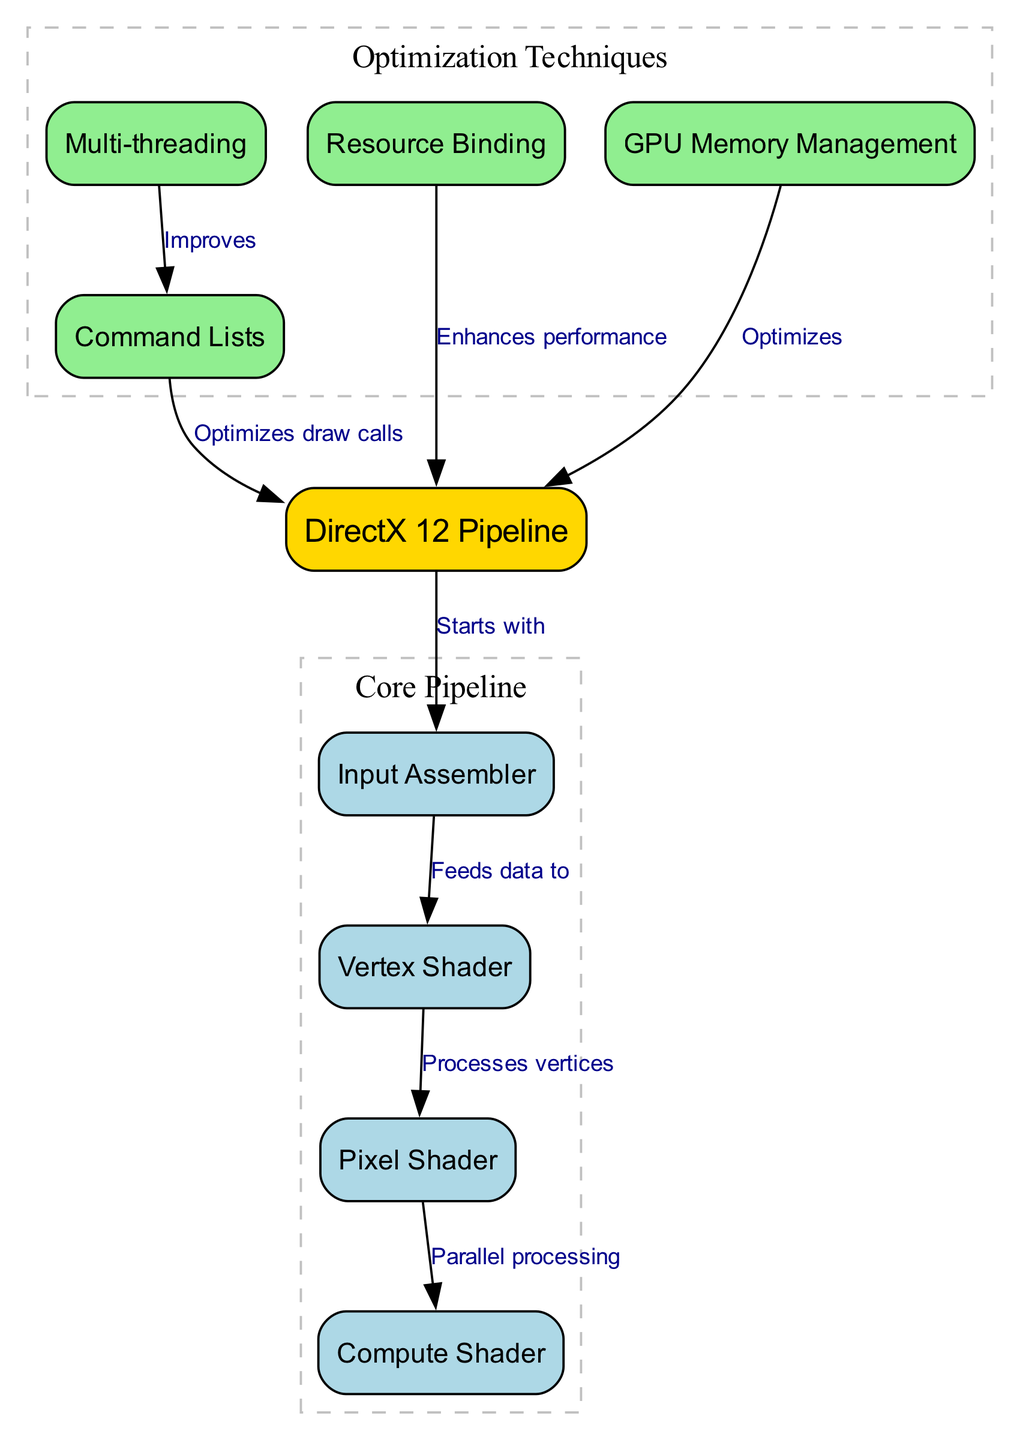What is the starting component of the DirectX 12 pipeline? The diagram indicates that the DirectX 12 Pipeline begins with the Input Assembler node, as it has an edge labeled "Starts with" leading from the DirectX 12 Pipeline to the Input Assembler.
Answer: Input Assembler How many components are in the core pipeline? The core pipeline comprises four key nodes: Input Assembler, Vertex Shader, Pixel Shader, and Compute Shader, which can be visually grouped together, and there are four nodes in total.
Answer: Four What does the Pixel Shader process? The diagram shows an edge labeled "Processes vertices" pointing from the Vertex Shader to the Pixel Shader, indicating that it processes the output of the Vertex Shader.
Answer: Vertices Which node enhances performance through resource binding? The diagram has an edge labeled "Enhances performance" leading from the Resource Binding node to the DirectX 12 Pipeline node, signifying that resource binding plays a role in performance enhancement.
Answer: Resource Binding What optimization technique improves command lists? The Multi-threading node is shown with an edge labeled "Improves" leading to the Command Lists node, indicating that it provides an improvement in this area.
Answer: Multi-threading How does the command list affect the DirectX 12 Pipeline? The diagram states that the Command Lists node has an edge labeled "Optimizes draw calls" leading back to the DirectX 12 Pipeline, demonstrating that it optimizes the drawing process within the pipeline.
Answer: Optimizes draw calls Which technique is associated with GPU memory management? The edge labeled "Optimizes" from the GPU Memory Management node to the DirectX 12 Pipeline node indicates that it is an optimization technique associated with the pipeline.
Answer: Optimizes What is the relationship between the Vertex Shader and the Pixel Shader? The diagram depicts a direct edge from the Vertex Shader to the Pixel Shader labeled "Processes vertices," demonstrating a direct flow of processed data between these two nodes.
Answer: Feeds data to How many optimization techniques are listed in the diagram? There are four optimization techniques represented by the nodes: Command Lists, Multi-threading, Resource Binding, and GPU Memory Management, counting them yields a total of four techniques.
Answer: Four 